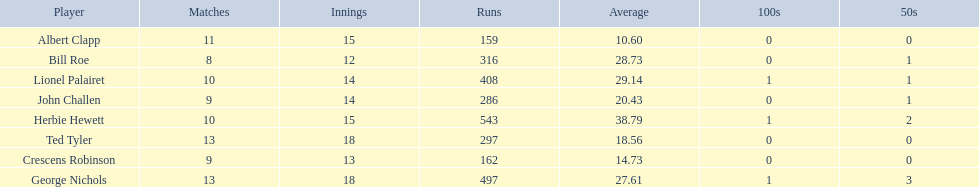Name a player that play in no more than 13 innings. Bill Roe. 